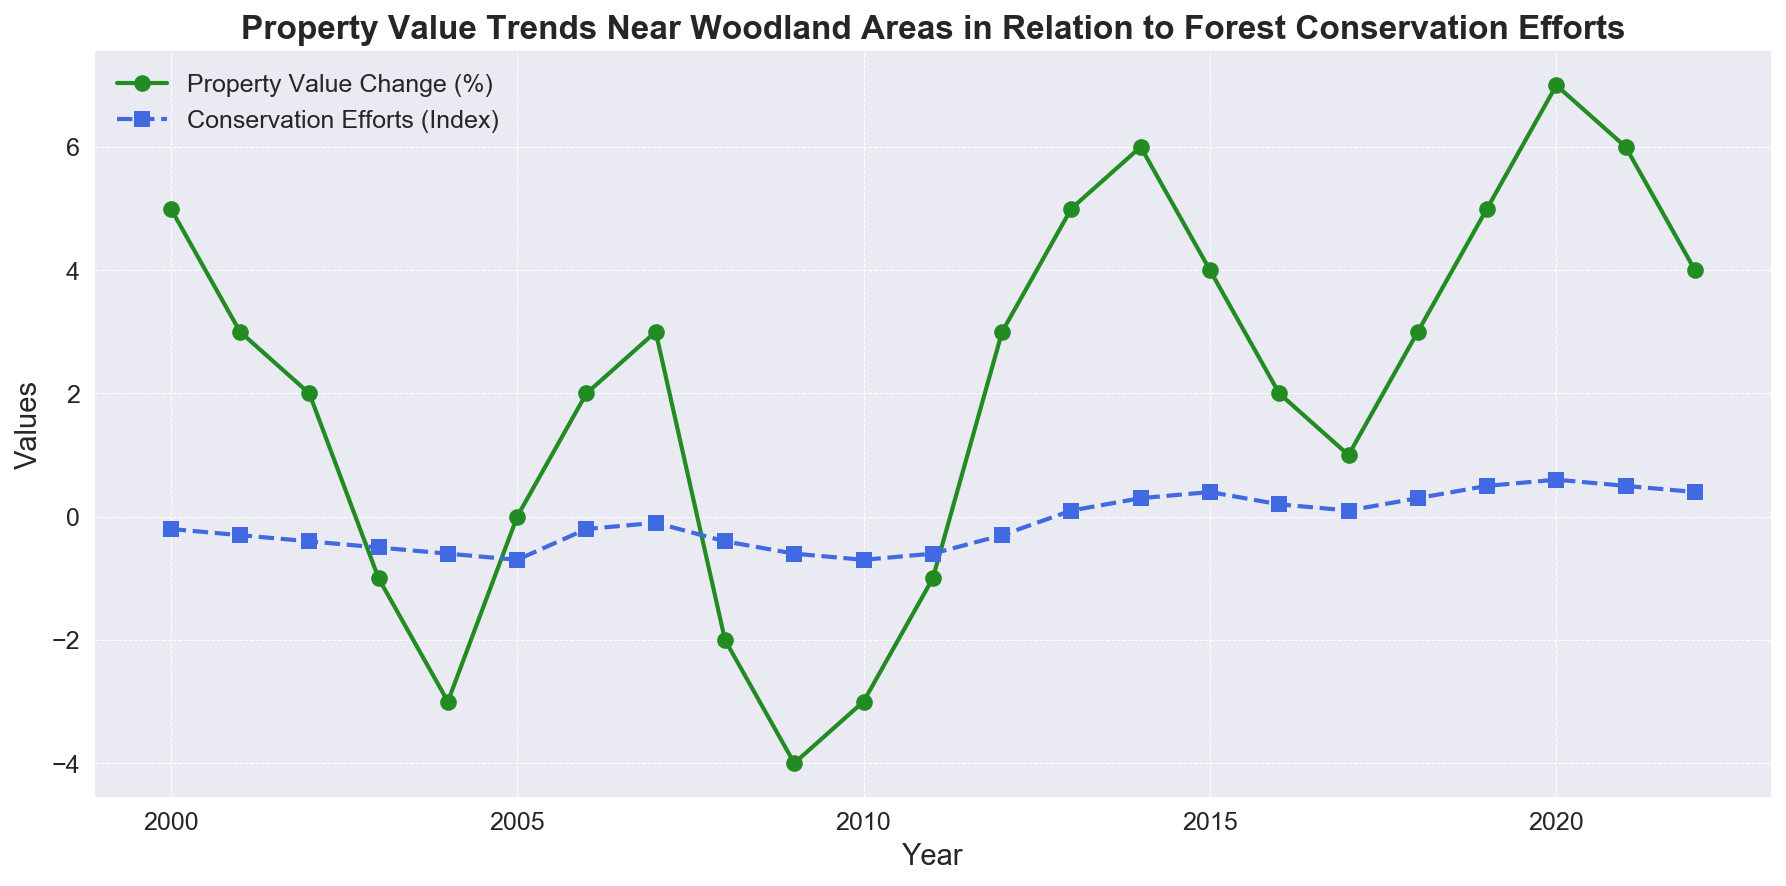What's the trend of property values from 2000 to 2022? Over the period from 2000 to 2022, the property values show fluctuations with both positive and negative changes, starting at 5% in 2000, experiencing a low of -4% in 2009, and ending with a peak of 7% in 2020. The general trend is incremental towards the end of the period.
Answer: Fluctuating with an upward trend towards the end How do the property value changes in 2004 and 2009 compare? Comparing the property values in 2004 and 2009, we can see that both years exhibit a decrease in property values, with 2004 having a -3% change and 2009 having a -4% change.
Answer: 2009 is lower by 1% Which year shows the highest property value change? Reviewing all the years, the highest property value change occurs in 2020 with a 7% increase.
Answer: 2020 How does the Conservation Efforts Index change from 2000 to 2022? The Conservation Efforts Index starts at -0.2 in 2000, decreases to a low of -0.7 in 2010, and then increases steadily to 0.4 in 2022.
Answer: Decreases initially, then increases towards the end What year marks the lowest point for conservation efforts? The conservation efforts index reaches its lowest point at -0.7 in the years 2005 and 2010.
Answer: 2005 and 2010 Is there a year where both property value change and conservation efforts index are positive? Yes, in 2013, both property value change (5%) and conservation efforts index (0.1) are positive.
Answer: 2013 What is the overall trend of the Conservation Efforts Index from 2010 to 2022? From 2010 onwards, the trend of the Conservation Efforts Index sees a steady increase, moving from -0.7 in 2010 to 0.4 in 2022.
Answer: Steady increase Which year shows the highest positive difference between property value change and conservation efforts index? The year 2020 shows the highest positive difference of 7 - 0.6 = 6.4 percentage points.
Answer: 2020 